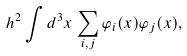Convert formula to latex. <formula><loc_0><loc_0><loc_500><loc_500>h ^ { 2 } \int d ^ { 3 } x \, \sum _ { i , j } \varphi _ { i } ( x ) \varphi _ { j } ( x ) ,</formula> 